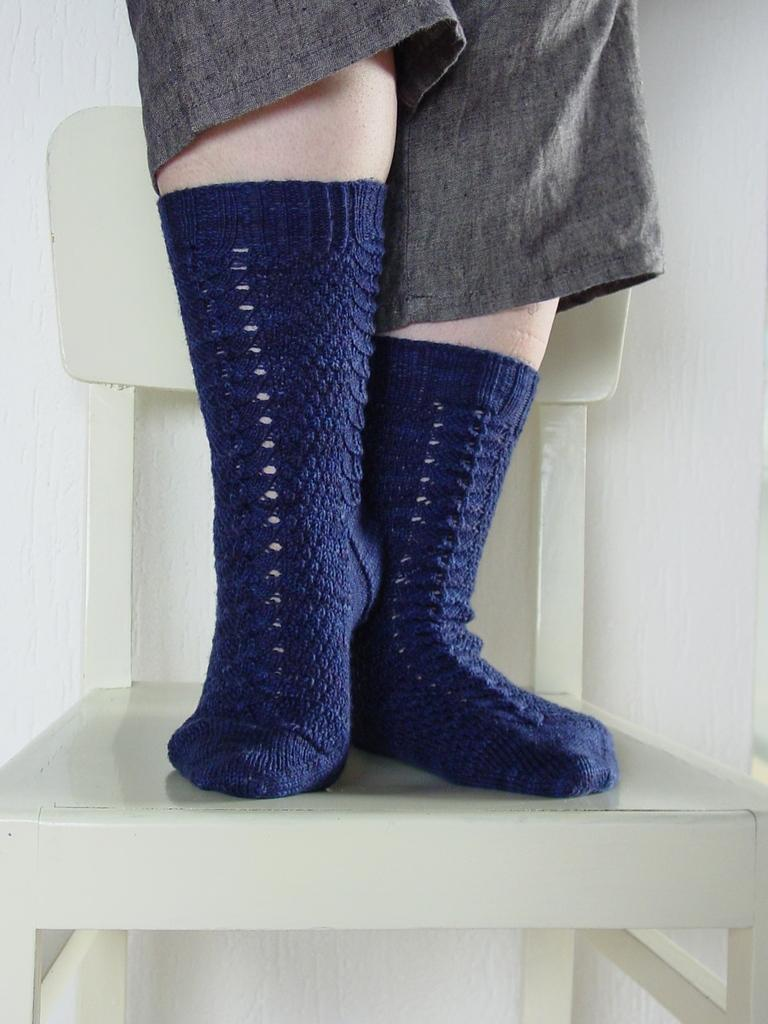What color is the chair in the image? The chair in the image is white. What is the person doing with the chair? The person's legs are on the chair. What color are the person's socks? The person is wearing blue socks. What color are the person's pants? The person is wearing grey pants. What can be seen behind the chair in the image? A: There is a white wall behind the chair. What type of account does the person have with the queen in the image? There is no mention of a queen or an account in the image; it only features a white chair, a person's legs, blue socks, grey pants, and a white wall. 